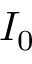<formula> <loc_0><loc_0><loc_500><loc_500>I _ { 0 }</formula> 